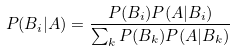<formula> <loc_0><loc_0><loc_500><loc_500>P ( B _ { i } | A ) = \frac { P ( B _ { i } ) P ( A | B _ { i } ) } { \sum _ { k } P ( B _ { k } ) P ( A | B _ { k } ) }</formula> 